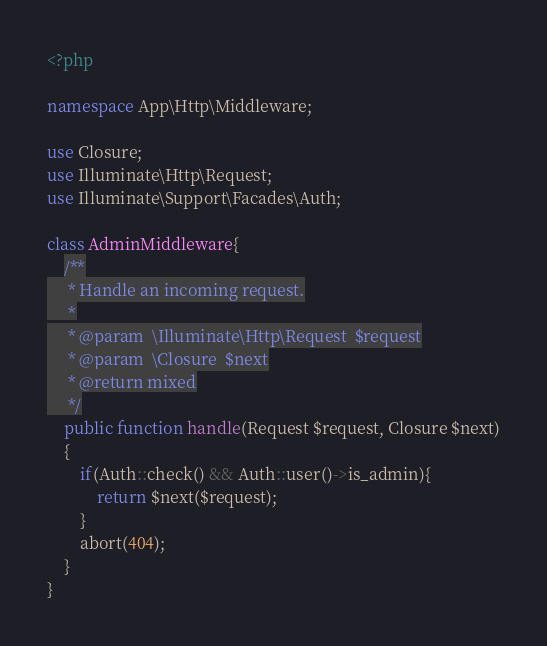Convert code to text. <code><loc_0><loc_0><loc_500><loc_500><_PHP_><?php

namespace App\Http\Middleware;

use Closure;
use Illuminate\Http\Request;
use Illuminate\Support\Facades\Auth;

class AdminMiddleware{
    /**
     * Handle an incoming request.
     *
     * @param  \Illuminate\Http\Request  $request
     * @param  \Closure  $next
     * @return mixed
     */
    public function handle(Request $request, Closure $next)
    {
        if(Auth::check() && Auth::user()->is_admin){
            return $next($request);
        }
        abort(404);
    }
}
</code> 